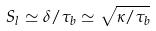Convert formula to latex. <formula><loc_0><loc_0><loc_500><loc_500>S _ { l } \simeq \delta / \tau _ { b } \simeq \sqrt { \kappa / \tau _ { b } }</formula> 